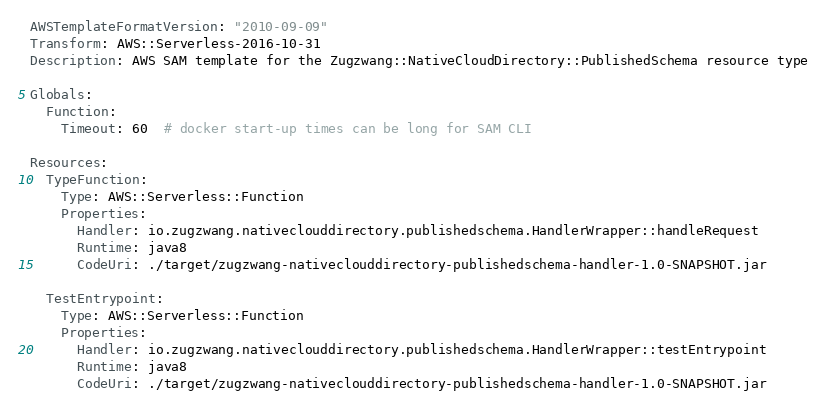Convert code to text. <code><loc_0><loc_0><loc_500><loc_500><_YAML_>AWSTemplateFormatVersion: "2010-09-09"
Transform: AWS::Serverless-2016-10-31
Description: AWS SAM template for the Zugzwang::NativeCloudDirectory::PublishedSchema resource type

Globals:
  Function:
    Timeout: 60  # docker start-up times can be long for SAM CLI

Resources:
  TypeFunction:
    Type: AWS::Serverless::Function
    Properties:
      Handler: io.zugzwang.nativeclouddirectory.publishedschema.HandlerWrapper::handleRequest
      Runtime: java8
      CodeUri: ./target/zugzwang-nativeclouddirectory-publishedschema-handler-1.0-SNAPSHOT.jar

  TestEntrypoint:
    Type: AWS::Serverless::Function
    Properties:
      Handler: io.zugzwang.nativeclouddirectory.publishedschema.HandlerWrapper::testEntrypoint
      Runtime: java8
      CodeUri: ./target/zugzwang-nativeclouddirectory-publishedschema-handler-1.0-SNAPSHOT.jar

</code> 